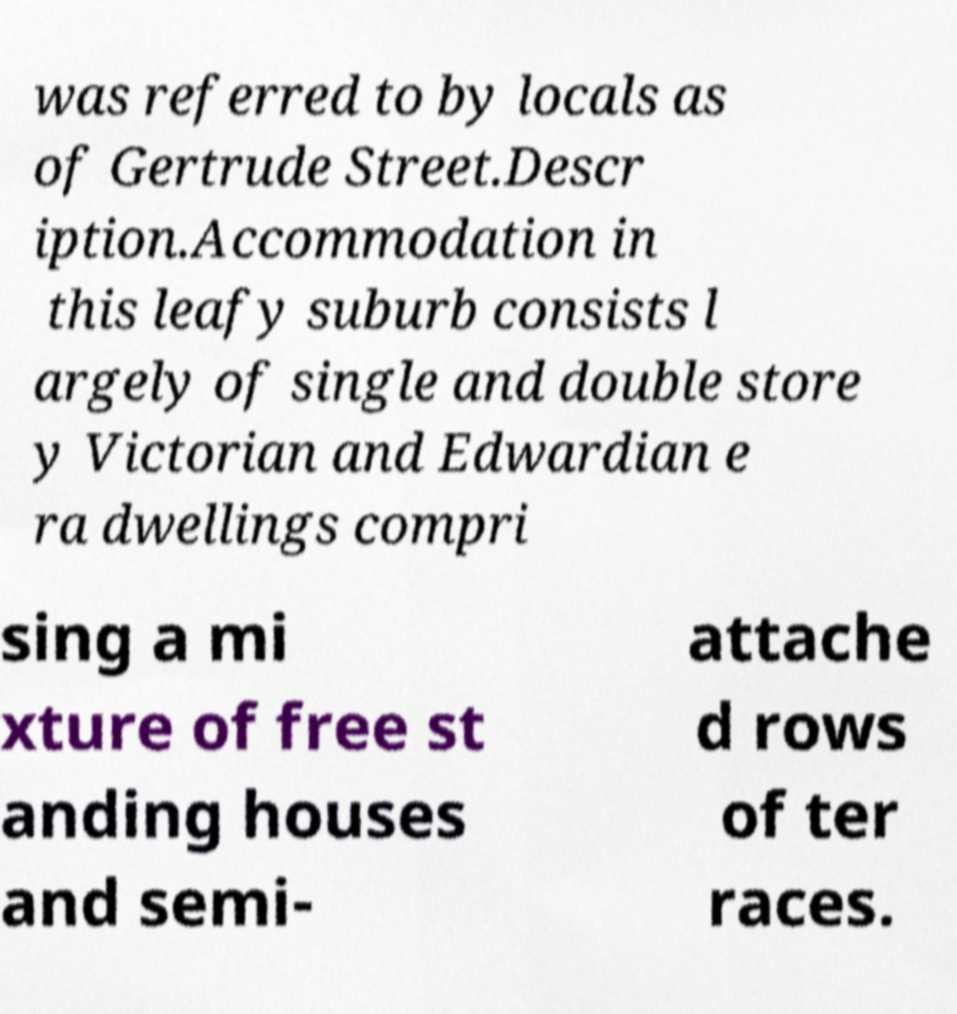Could you assist in decoding the text presented in this image and type it out clearly? was referred to by locals as of Gertrude Street.Descr iption.Accommodation in this leafy suburb consists l argely of single and double store y Victorian and Edwardian e ra dwellings compri sing a mi xture of free st anding houses and semi- attache d rows of ter races. 